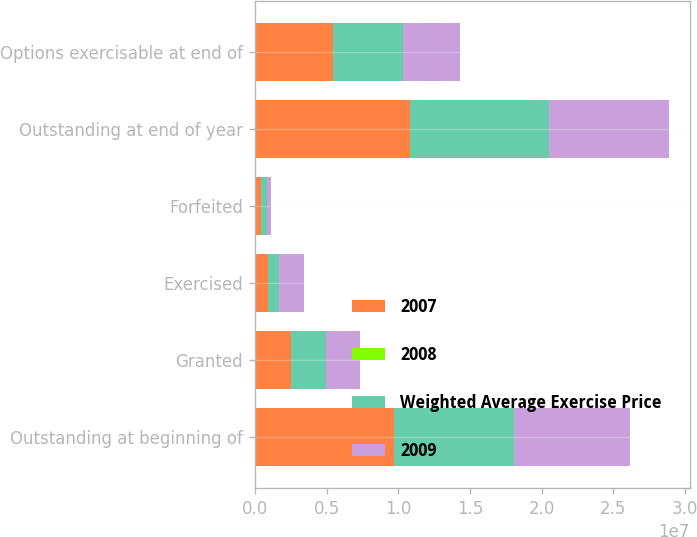<chart> <loc_0><loc_0><loc_500><loc_500><stacked_bar_chart><ecel><fcel>Outstanding at beginning of<fcel>Granted<fcel>Exercised<fcel>Forfeited<fcel>Outstanding at end of year<fcel>Options exercisable at end of<nl><fcel>2007<fcel>9.68382e+06<fcel>2.49095e+06<fcel>923964<fcel>451500<fcel>1.07993e+07<fcel>5.45305e+06<nl><fcel>2008<fcel>34.69<fcel>31.81<fcel>21.96<fcel>42.09<fcel>34.82<fcel>31.61<nl><fcel>Weighted Average Exercise Price<fcel>8.40648e+06<fcel>2.46965e+06<fcel>786523<fcel>405794<fcel>9.68382e+06<fcel>4.88448e+06<nl><fcel>2009<fcel>8.10289e+06<fcel>2.35365e+06<fcel>1.74733e+06<fcel>302729<fcel>8.40648e+06<fcel>4.00116e+06<nl></chart> 